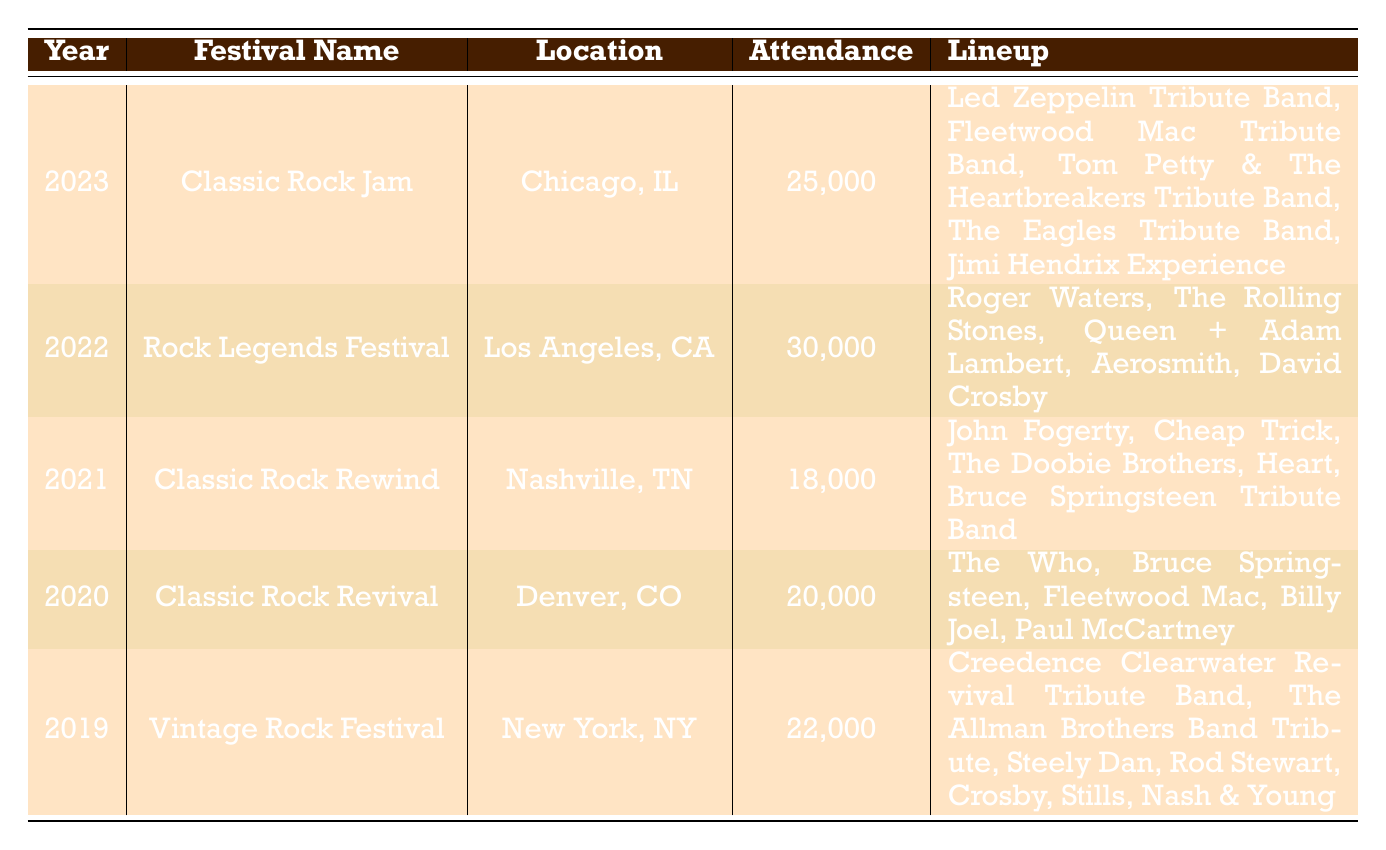What was the highest attendance recorded at a classic rock festival from 2019 to 2023? By checking the attendance values for the years 2019 (22,000), 2020 (20,000), 2021 (18,000), 2022 (30,000), and 2023 (25,000), the highest is 30,000 in 2022 at the Rock Legends Festival.
Answer: 30,000 Which festival took place in Los Angeles? The table indicates that the Rock Legends Festival was held in Los Angeles, CA, in 2022.
Answer: Rock Legends Festival What is the average attendance for the festivals from 2019 to 2023? Summing the attendance values: 22,000 (2019) + 20,000 (2020) + 18,000 (2021) + 30,000 (2022) + 25,000 (2023) gives 115,000. Dividing this by 5 (the number of years), we get 23,000.
Answer: 23,000 Did the Classic Rock Jam in 2023 feature any tribute bands? Looking at the lineup for the Classic Rock Jam in 2023, several acts are listed as tribute bands. Therefore, the answer is yes.
Answer: Yes Which festival had the most diverse lineup in terms of legendary artists? Comparing the lineups, the Rock Legends Festival in 2022 featured a mix of famous artists including Roger Waters, The Rolling Stones, Queen + Adam Lambert, Aerosmith, and David Crosby, showcasing a broader range of classic rock legends compared to tribute acts.
Answer: Rock Legends Festival What is the difference in attendance between the Classic Rock Jam and the Classic Rock Rewind? The Classic Rock Jam had an attendance of 25,000 in 2023, while the Classic Rock Rewind had 18,000 in 2021. The difference is 25,000 - 18,000 = 7,000.
Answer: 7,000 Which year had the fewest attendees, and what was that number? In reviewing the attendance figures, 18,000 recorded in 2021 for the Classic Rock Rewind is the lowest.
Answer: 18,000 Are there any festivals in this table that took place in Chicago? The table indicates that only the Classic Rock Jam in 2023 was held in Chicago, IL. Therefore, there is one festival in Chicago.
Answer: Yes 